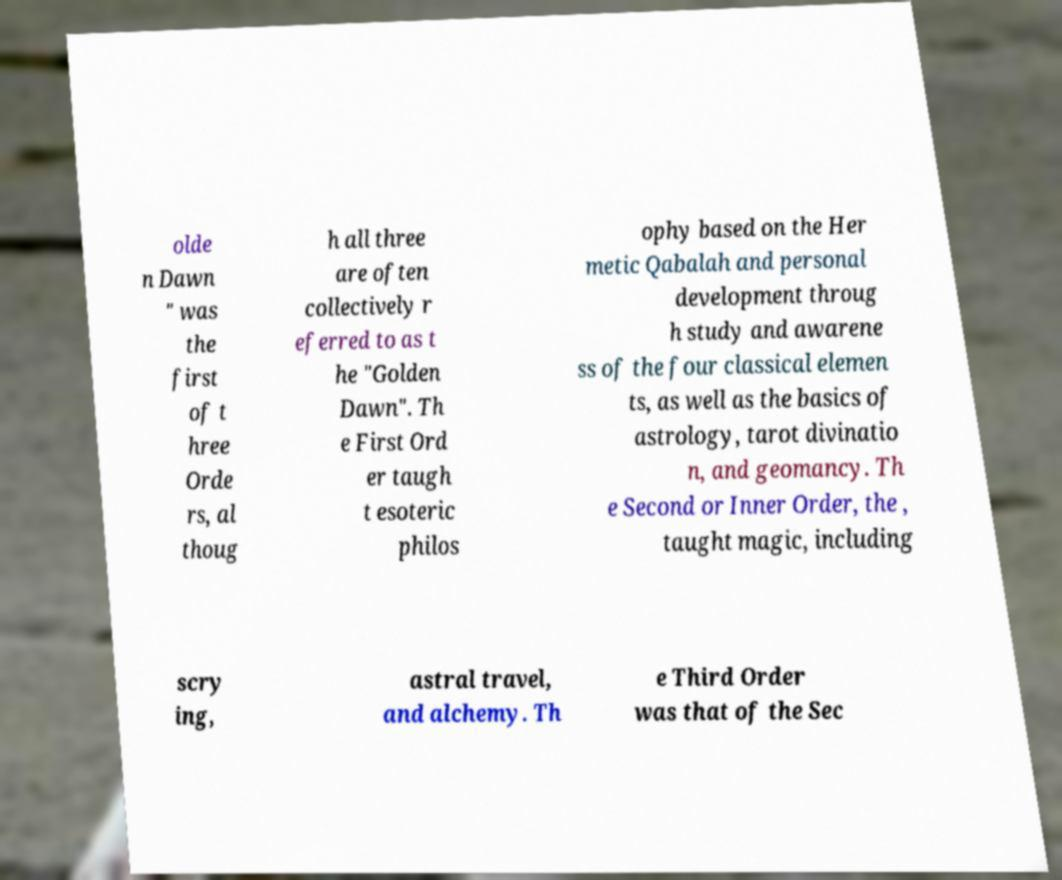Could you assist in decoding the text presented in this image and type it out clearly? olde n Dawn " was the first of t hree Orde rs, al thoug h all three are often collectively r eferred to as t he "Golden Dawn". Th e First Ord er taugh t esoteric philos ophy based on the Her metic Qabalah and personal development throug h study and awarene ss of the four classical elemen ts, as well as the basics of astrology, tarot divinatio n, and geomancy. Th e Second or Inner Order, the , taught magic, including scry ing, astral travel, and alchemy. Th e Third Order was that of the Sec 